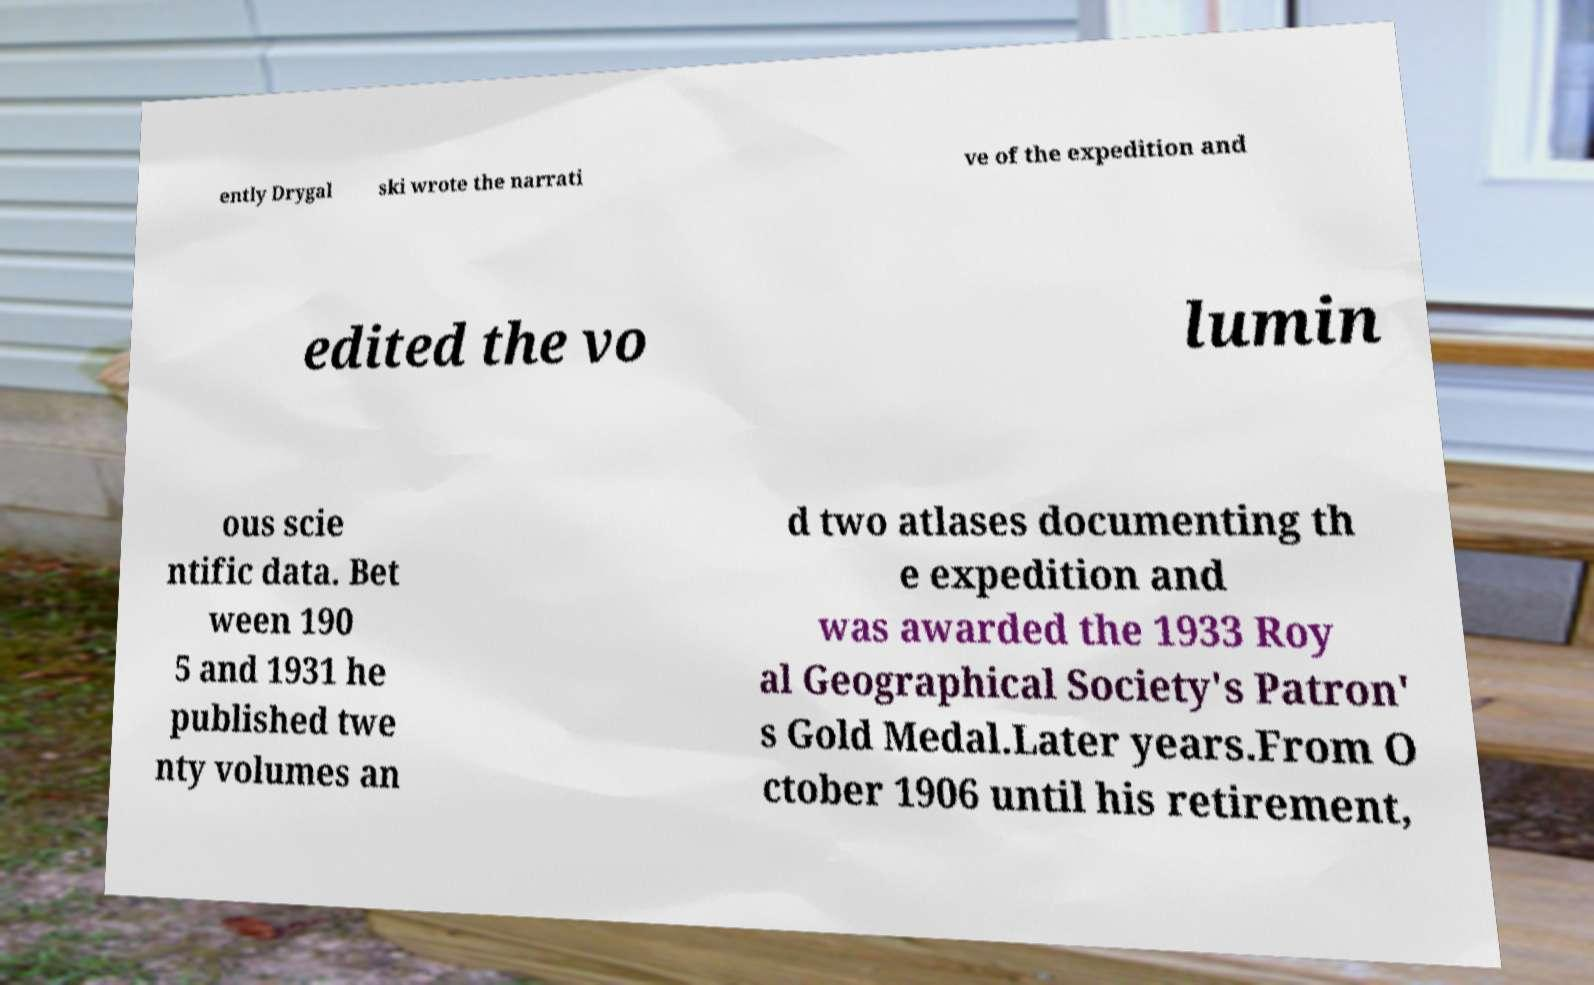Can you read and provide the text displayed in the image?This photo seems to have some interesting text. Can you extract and type it out for me? ently Drygal ski wrote the narrati ve of the expedition and edited the vo lumin ous scie ntific data. Bet ween 190 5 and 1931 he published twe nty volumes an d two atlases documenting th e expedition and was awarded the 1933 Roy al Geographical Society's Patron' s Gold Medal.Later years.From O ctober 1906 until his retirement, 